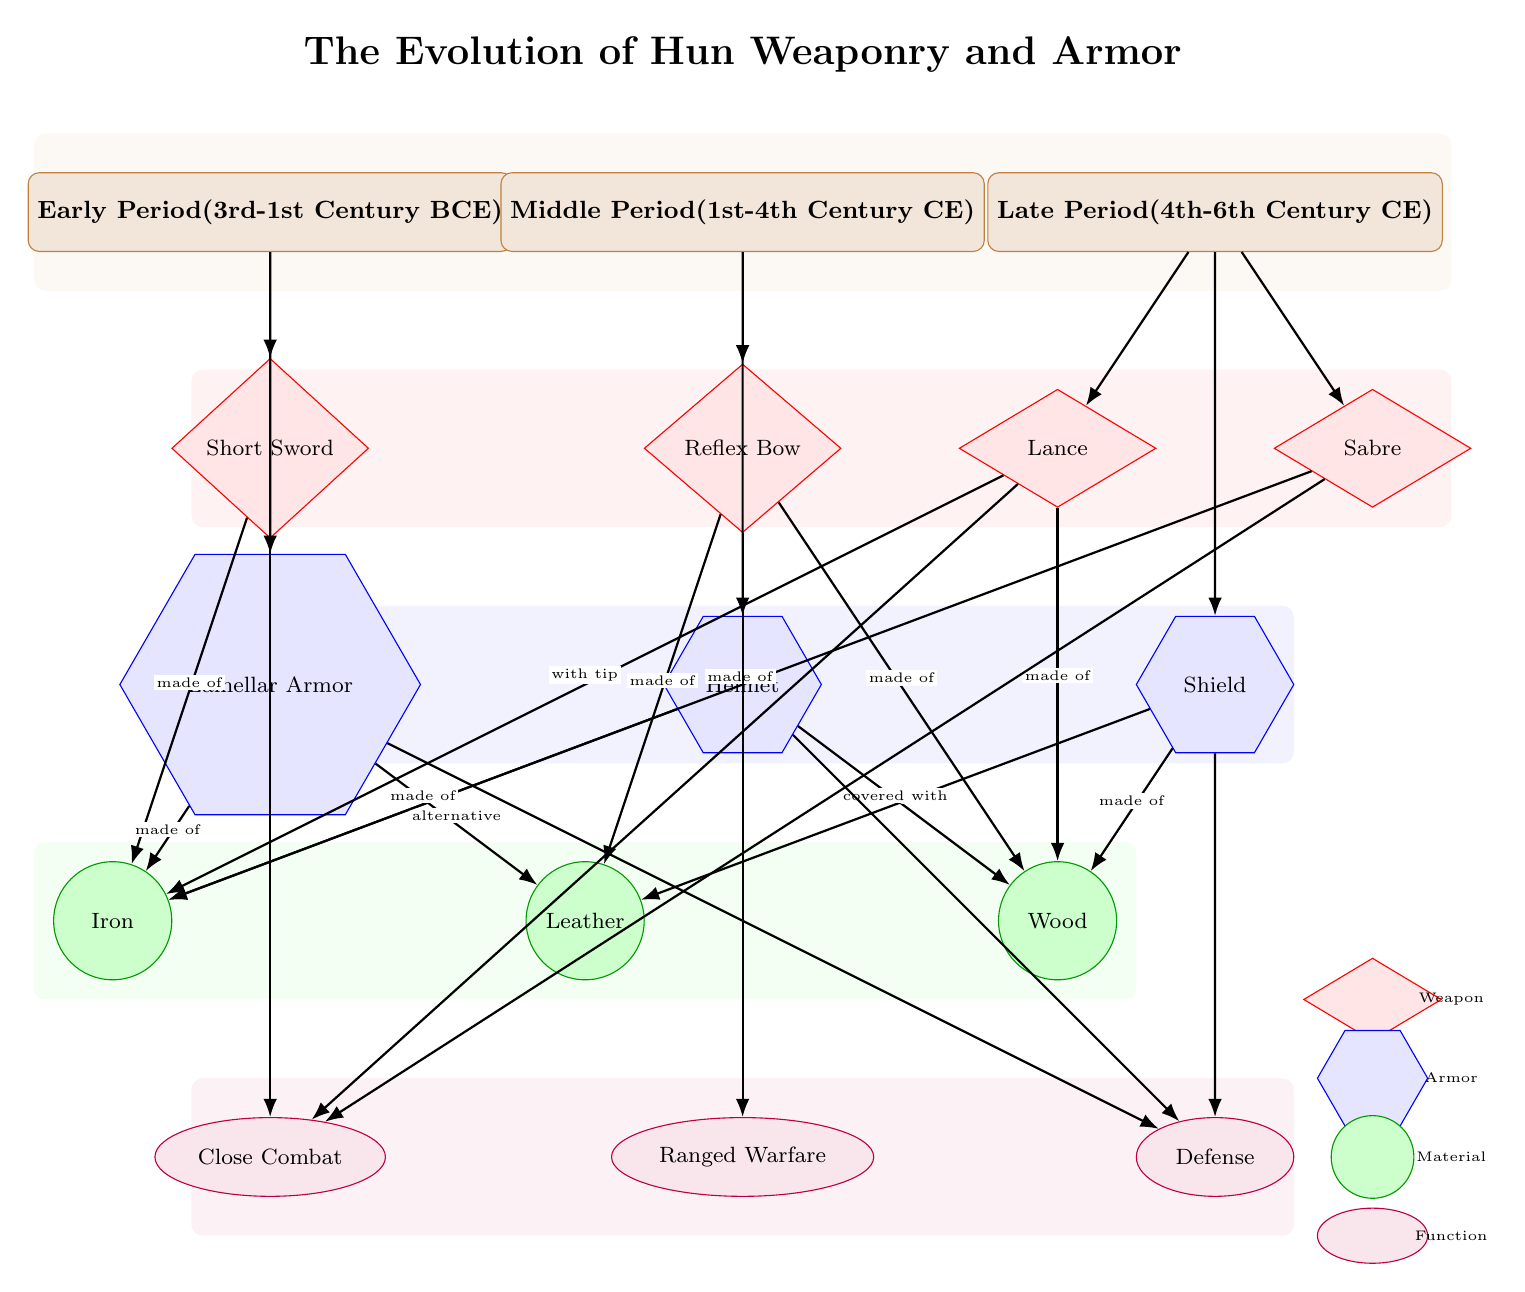What is the type of weapon associated with the early period? The diagram indicates that the weapon associated with the early period is the "Short Sword," which is represented directly under the early period node.
Answer: Short Sword What materials were used for the Reflex Bow? The diagram shows that the Reflex Bow is made of "Leather" and "Wood." Both materials are indicated by arrows originating from the Reflex Bow node.
Answer: Leather, Wood How many types of armor are listed in the diagram? The diagram displays three distinct types of armor: "Lamellar Armor," "Helmet," and "Shield," which can be counted directly from the armor nodes.
Answer: 3 What function is associated with the Lance? The diagram links the Lance to the "Close Combat" function, which is found beneath the Lance node. It shows that the Lance is utilized for melee engagements.
Answer: Close Combat Which materials are indicated as alternatives for Lamellar Armor? The diagram specifies "Iron" as the primary material and "Leather" as an alternative for Lamellar Armor, as both materials are connected by arrows pointing to the Lamellar Armor node.
Answer: Leather What period does the Sabre belong to? According to the diagram, the Sabre is listed under the Late Period, which spans from the 4th to the 6th Century CE, as shown in the period nodes above the Sabre.
Answer: Late Period What is the primary function of the Shield? The diagram indicates that the Shield serves the function of "Defense," which can be traced through the arrows connecting the Shield node to the function node below.
Answer: Defense What is the total number of weapons listed in the diagram? The diagram lists four specific weapons: "Short Sword," "Reflex Bow," "Lance," and "Sabre." This count can be verified by counting the weapon nodes directly shown in the diagram.
Answer: 4 What is the material used in the construction of the Helmet? The diagram illustrates that the Helmet is made of "Iron," as indicated by the arrow connecting the Helmet to the Iron material node.
Answer: Iron 